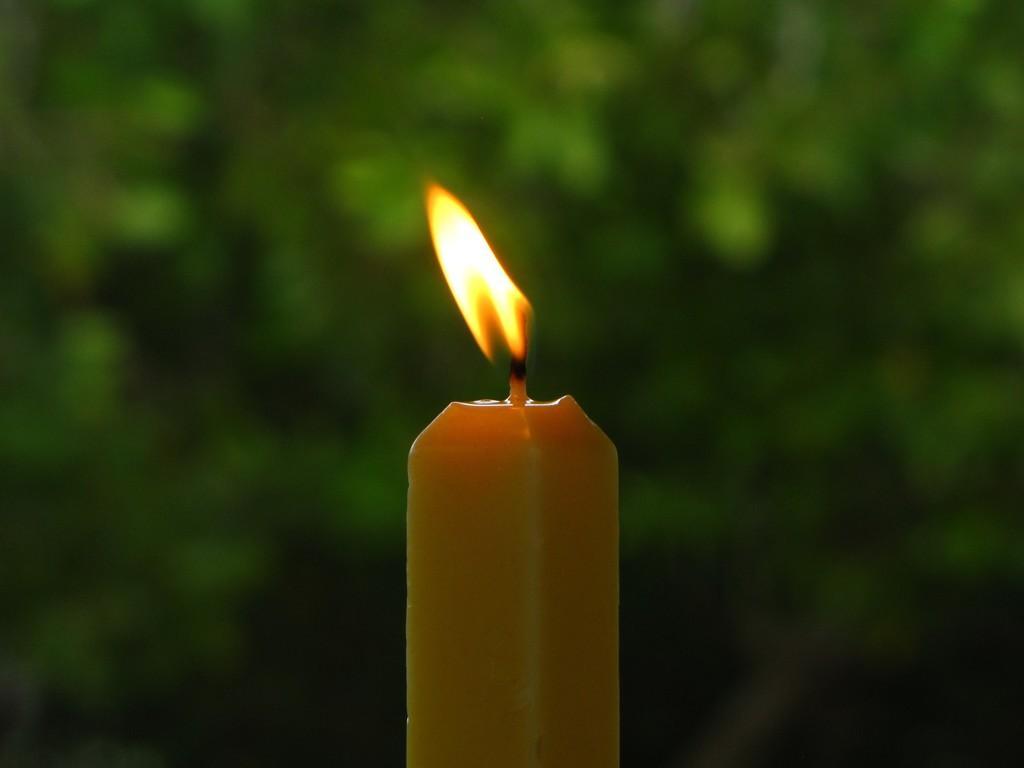Could you give a brief overview of what you see in this image? In this image there is a candle. 